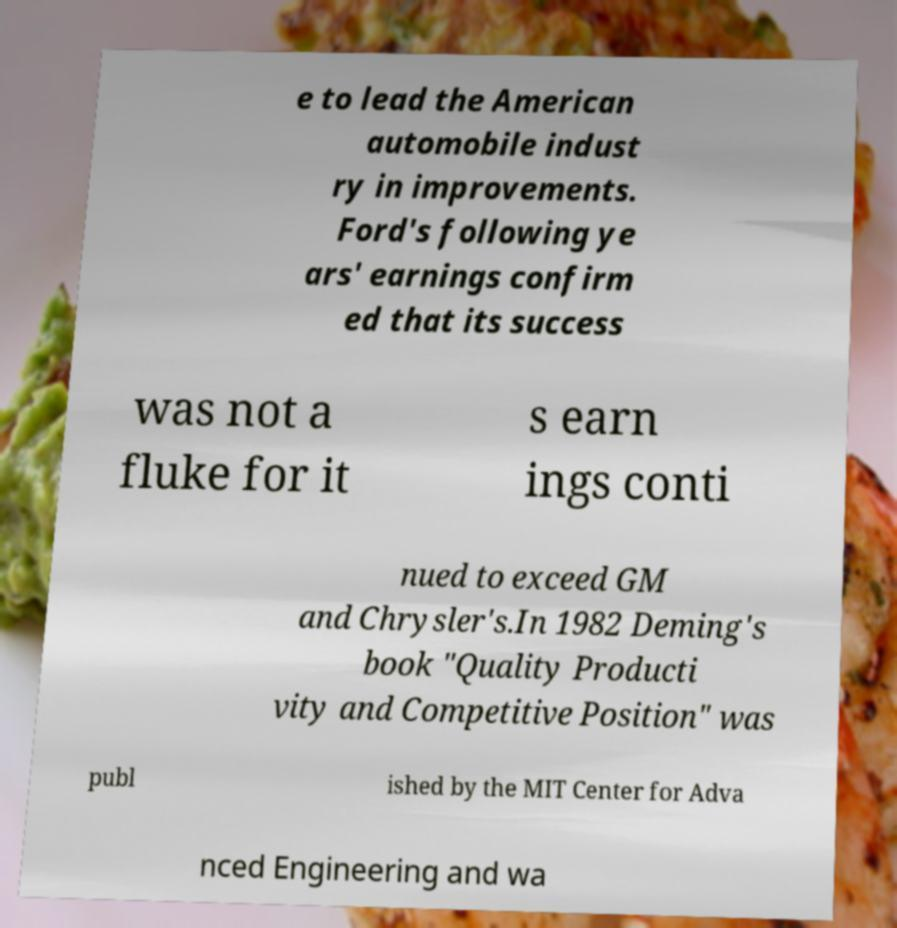Can you accurately transcribe the text from the provided image for me? e to lead the American automobile indust ry in improvements. Ford's following ye ars' earnings confirm ed that its success was not a fluke for it s earn ings conti nued to exceed GM and Chrysler's.In 1982 Deming's book "Quality Producti vity and Competitive Position" was publ ished by the MIT Center for Adva nced Engineering and wa 